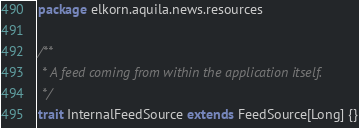<code> <loc_0><loc_0><loc_500><loc_500><_Scala_>package elkorn.aquila.news.resources

/**
 * A feed coming from within the application itself.
 */
trait InternalFeedSource extends FeedSource[Long] {}
</code> 